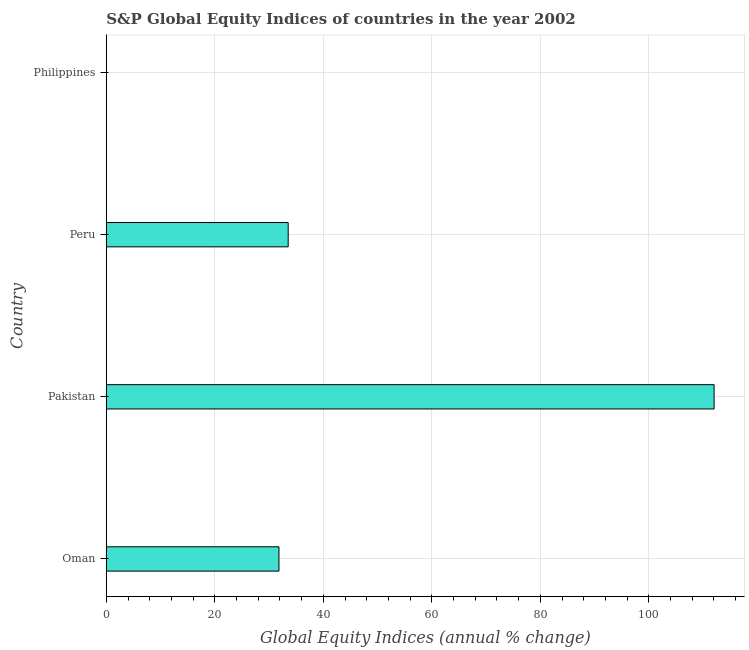Does the graph contain grids?
Provide a short and direct response. Yes. What is the title of the graph?
Offer a terse response. S&P Global Equity Indices of countries in the year 2002. What is the label or title of the X-axis?
Make the answer very short. Global Equity Indices (annual % change). What is the label or title of the Y-axis?
Ensure brevity in your answer.  Country. What is the s&p global equity indices in Pakistan?
Give a very brief answer. 112.03. Across all countries, what is the maximum s&p global equity indices?
Make the answer very short. 112.03. What is the sum of the s&p global equity indices?
Offer a very short reply. 177.37. What is the average s&p global equity indices per country?
Offer a terse response. 44.34. What is the median s&p global equity indices?
Provide a short and direct response. 32.67. In how many countries, is the s&p global equity indices greater than 52 %?
Your response must be concise. 1. What is the ratio of the s&p global equity indices in Oman to that in Peru?
Give a very brief answer. 0.95. Is the difference between the s&p global equity indices in Oman and Pakistan greater than the difference between any two countries?
Offer a very short reply. No. What is the difference between the highest and the second highest s&p global equity indices?
Give a very brief answer. 78.51. Is the sum of the s&p global equity indices in Pakistan and Peru greater than the maximum s&p global equity indices across all countries?
Your answer should be very brief. Yes. What is the difference between the highest and the lowest s&p global equity indices?
Provide a short and direct response. 112.03. How many bars are there?
Your answer should be very brief. 3. How many countries are there in the graph?
Provide a short and direct response. 4. Are the values on the major ticks of X-axis written in scientific E-notation?
Give a very brief answer. No. What is the Global Equity Indices (annual % change) of Oman?
Offer a terse response. 31.82. What is the Global Equity Indices (annual % change) in Pakistan?
Provide a short and direct response. 112.03. What is the Global Equity Indices (annual % change) of Peru?
Offer a very short reply. 33.52. What is the Global Equity Indices (annual % change) in Philippines?
Keep it short and to the point. 0. What is the difference between the Global Equity Indices (annual % change) in Oman and Pakistan?
Provide a short and direct response. -80.21. What is the difference between the Global Equity Indices (annual % change) in Oman and Peru?
Give a very brief answer. -1.7. What is the difference between the Global Equity Indices (annual % change) in Pakistan and Peru?
Ensure brevity in your answer.  78.51. What is the ratio of the Global Equity Indices (annual % change) in Oman to that in Pakistan?
Offer a terse response. 0.28. What is the ratio of the Global Equity Indices (annual % change) in Oman to that in Peru?
Ensure brevity in your answer.  0.95. What is the ratio of the Global Equity Indices (annual % change) in Pakistan to that in Peru?
Keep it short and to the point. 3.34. 